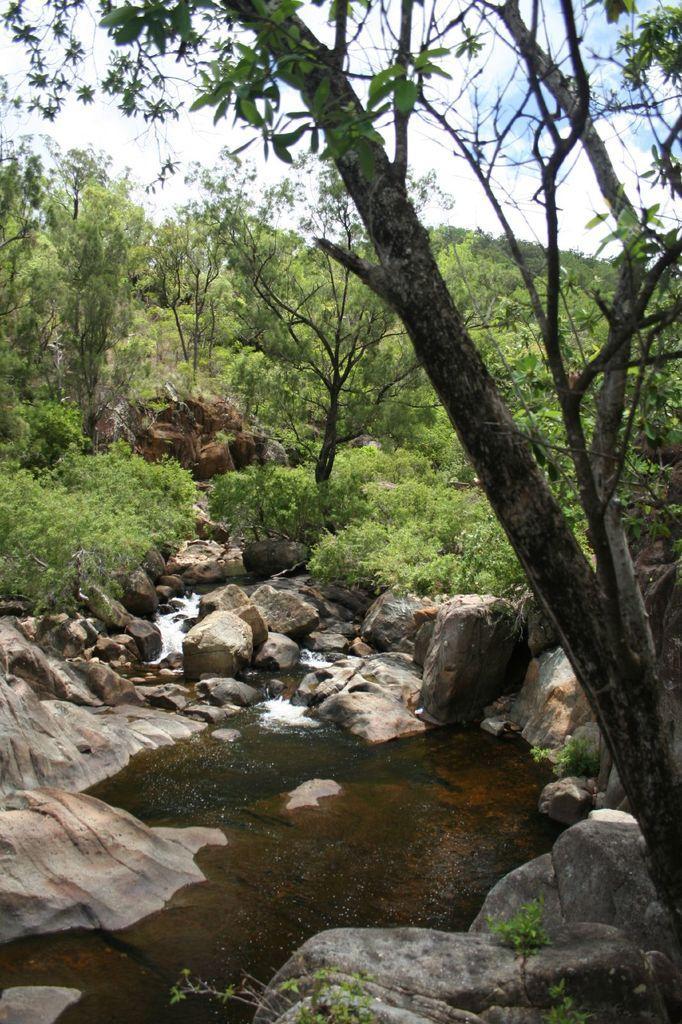In one or two sentences, can you explain what this image depicts? In this image we can see a group of trees, the rocks, plants, water and the sky which looks cloudy. 